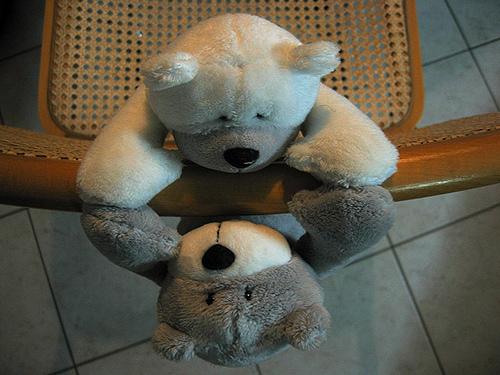Is this teddy bear looking at its own reflection?
Answer briefly. No. What is the chair made of?
Keep it brief. Wood. What is the bear sitting on?
Write a very short answer. Chair. Are these teddy bears brother and sister?
Give a very brief answer. Yes. 